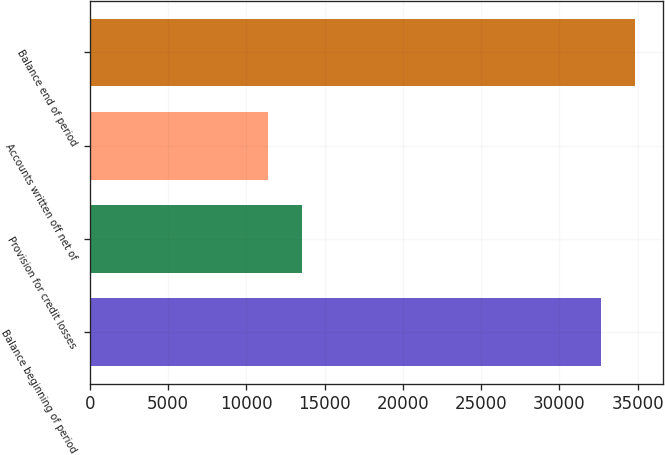Convert chart. <chart><loc_0><loc_0><loc_500><loc_500><bar_chart><fcel>Balance beginning of period<fcel>Provision for credit losses<fcel>Accounts written off net of<fcel>Balance end of period<nl><fcel>32681<fcel>13588.2<fcel>11400<fcel>34869.2<nl></chart> 